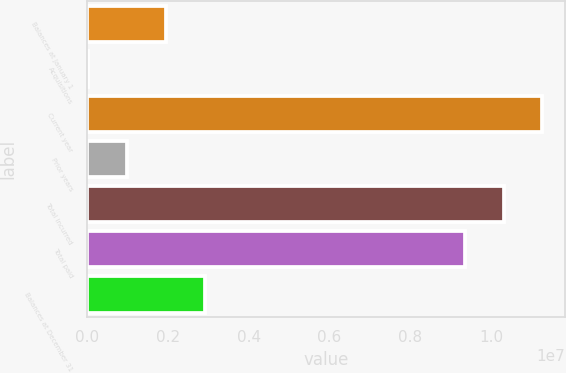Convert chart to OTSL. <chart><loc_0><loc_0><loc_500><loc_500><bar_chart><fcel>Balances at January 1<fcel>Acquisitions<fcel>Current year<fcel>Prior years<fcel>Total incurred<fcel>Total paid<fcel>Balances at December 31<nl><fcel>1.95699e+06<fcel>37375<fcel>1.12591e+07<fcel>997181<fcel>1.02993e+07<fcel>9.33954e+06<fcel>2.91679e+06<nl></chart> 